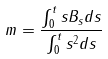<formula> <loc_0><loc_0><loc_500><loc_500>m = \frac { \int _ { 0 } ^ { t } s B _ { s } d s } { \int _ { 0 } ^ { t } s ^ { 2 } d s }</formula> 